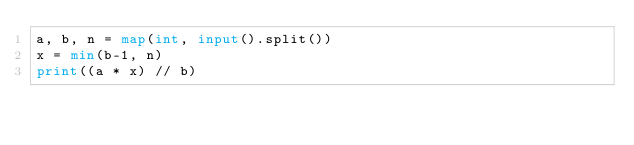Convert code to text. <code><loc_0><loc_0><loc_500><loc_500><_Python_>a, b, n = map(int, input().split())
x = min(b-1, n)
print((a * x) // b)
</code> 